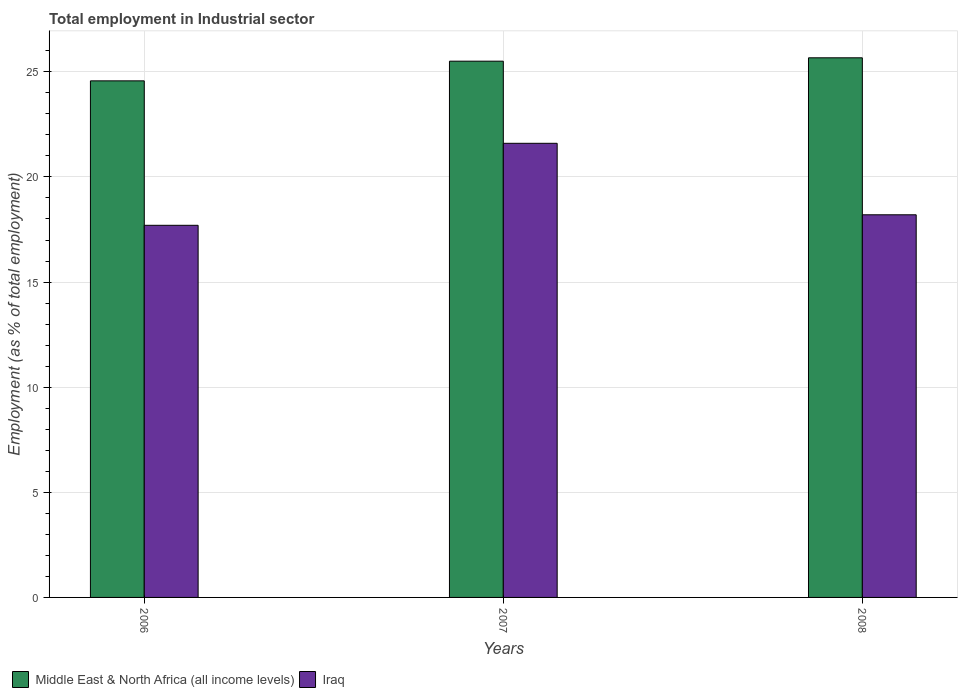How many groups of bars are there?
Offer a very short reply. 3. Are the number of bars on each tick of the X-axis equal?
Ensure brevity in your answer.  Yes. How many bars are there on the 3rd tick from the left?
Offer a very short reply. 2. What is the label of the 2nd group of bars from the left?
Your answer should be compact. 2007. What is the employment in industrial sector in Middle East & North Africa (all income levels) in 2008?
Ensure brevity in your answer.  25.67. Across all years, what is the maximum employment in industrial sector in Middle East & North Africa (all income levels)?
Offer a very short reply. 25.67. Across all years, what is the minimum employment in industrial sector in Iraq?
Provide a succinct answer. 17.7. In which year was the employment in industrial sector in Iraq maximum?
Provide a short and direct response. 2007. What is the total employment in industrial sector in Iraq in the graph?
Provide a succinct answer. 57.5. What is the difference between the employment in industrial sector in Middle East & North Africa (all income levels) in 2006 and that in 2007?
Give a very brief answer. -0.94. What is the difference between the employment in industrial sector in Iraq in 2008 and the employment in industrial sector in Middle East & North Africa (all income levels) in 2007?
Your answer should be compact. -7.31. What is the average employment in industrial sector in Iraq per year?
Make the answer very short. 19.17. In the year 2008, what is the difference between the employment in industrial sector in Iraq and employment in industrial sector in Middle East & North Africa (all income levels)?
Provide a succinct answer. -7.47. In how many years, is the employment in industrial sector in Middle East & North Africa (all income levels) greater than 20 %?
Ensure brevity in your answer.  3. What is the ratio of the employment in industrial sector in Iraq in 2006 to that in 2008?
Make the answer very short. 0.97. Is the employment in industrial sector in Iraq in 2007 less than that in 2008?
Offer a very short reply. No. Is the difference between the employment in industrial sector in Iraq in 2006 and 2007 greater than the difference between the employment in industrial sector in Middle East & North Africa (all income levels) in 2006 and 2007?
Provide a succinct answer. No. What is the difference between the highest and the second highest employment in industrial sector in Middle East & North Africa (all income levels)?
Your response must be concise. 0.16. What is the difference between the highest and the lowest employment in industrial sector in Middle East & North Africa (all income levels)?
Ensure brevity in your answer.  1.1. In how many years, is the employment in industrial sector in Iraq greater than the average employment in industrial sector in Iraq taken over all years?
Keep it short and to the point. 1. What does the 1st bar from the left in 2007 represents?
Your answer should be compact. Middle East & North Africa (all income levels). What does the 2nd bar from the right in 2006 represents?
Your response must be concise. Middle East & North Africa (all income levels). How many bars are there?
Keep it short and to the point. 6. What is the difference between two consecutive major ticks on the Y-axis?
Your answer should be very brief. 5. Does the graph contain any zero values?
Your response must be concise. No. Where does the legend appear in the graph?
Your response must be concise. Bottom left. How many legend labels are there?
Keep it short and to the point. 2. How are the legend labels stacked?
Offer a very short reply. Horizontal. What is the title of the graph?
Offer a very short reply. Total employment in Industrial sector. What is the label or title of the X-axis?
Provide a short and direct response. Years. What is the label or title of the Y-axis?
Keep it short and to the point. Employment (as % of total employment). What is the Employment (as % of total employment) in Middle East & North Africa (all income levels) in 2006?
Your answer should be compact. 24.57. What is the Employment (as % of total employment) of Iraq in 2006?
Keep it short and to the point. 17.7. What is the Employment (as % of total employment) of Middle East & North Africa (all income levels) in 2007?
Give a very brief answer. 25.51. What is the Employment (as % of total employment) in Iraq in 2007?
Ensure brevity in your answer.  21.6. What is the Employment (as % of total employment) in Middle East & North Africa (all income levels) in 2008?
Make the answer very short. 25.67. What is the Employment (as % of total employment) in Iraq in 2008?
Ensure brevity in your answer.  18.2. Across all years, what is the maximum Employment (as % of total employment) in Middle East & North Africa (all income levels)?
Your answer should be compact. 25.67. Across all years, what is the maximum Employment (as % of total employment) of Iraq?
Your answer should be compact. 21.6. Across all years, what is the minimum Employment (as % of total employment) of Middle East & North Africa (all income levels)?
Your answer should be compact. 24.57. Across all years, what is the minimum Employment (as % of total employment) of Iraq?
Provide a succinct answer. 17.7. What is the total Employment (as % of total employment) of Middle East & North Africa (all income levels) in the graph?
Offer a terse response. 75.74. What is the total Employment (as % of total employment) in Iraq in the graph?
Your answer should be compact. 57.5. What is the difference between the Employment (as % of total employment) in Middle East & North Africa (all income levels) in 2006 and that in 2007?
Provide a short and direct response. -0.94. What is the difference between the Employment (as % of total employment) in Iraq in 2006 and that in 2007?
Your answer should be compact. -3.9. What is the difference between the Employment (as % of total employment) in Middle East & North Africa (all income levels) in 2006 and that in 2008?
Your answer should be very brief. -1.1. What is the difference between the Employment (as % of total employment) in Iraq in 2006 and that in 2008?
Your response must be concise. -0.5. What is the difference between the Employment (as % of total employment) in Middle East & North Africa (all income levels) in 2007 and that in 2008?
Give a very brief answer. -0.16. What is the difference between the Employment (as % of total employment) in Iraq in 2007 and that in 2008?
Your response must be concise. 3.4. What is the difference between the Employment (as % of total employment) of Middle East & North Africa (all income levels) in 2006 and the Employment (as % of total employment) of Iraq in 2007?
Provide a short and direct response. 2.97. What is the difference between the Employment (as % of total employment) of Middle East & North Africa (all income levels) in 2006 and the Employment (as % of total employment) of Iraq in 2008?
Keep it short and to the point. 6.37. What is the difference between the Employment (as % of total employment) of Middle East & North Africa (all income levels) in 2007 and the Employment (as % of total employment) of Iraq in 2008?
Your response must be concise. 7.31. What is the average Employment (as % of total employment) of Middle East & North Africa (all income levels) per year?
Your response must be concise. 25.25. What is the average Employment (as % of total employment) in Iraq per year?
Your response must be concise. 19.17. In the year 2006, what is the difference between the Employment (as % of total employment) in Middle East & North Africa (all income levels) and Employment (as % of total employment) in Iraq?
Keep it short and to the point. 6.87. In the year 2007, what is the difference between the Employment (as % of total employment) of Middle East & North Africa (all income levels) and Employment (as % of total employment) of Iraq?
Your response must be concise. 3.91. In the year 2008, what is the difference between the Employment (as % of total employment) of Middle East & North Africa (all income levels) and Employment (as % of total employment) of Iraq?
Provide a short and direct response. 7.47. What is the ratio of the Employment (as % of total employment) in Middle East & North Africa (all income levels) in 2006 to that in 2007?
Your answer should be compact. 0.96. What is the ratio of the Employment (as % of total employment) in Iraq in 2006 to that in 2007?
Provide a short and direct response. 0.82. What is the ratio of the Employment (as % of total employment) of Middle East & North Africa (all income levels) in 2006 to that in 2008?
Provide a short and direct response. 0.96. What is the ratio of the Employment (as % of total employment) of Iraq in 2006 to that in 2008?
Offer a terse response. 0.97. What is the ratio of the Employment (as % of total employment) of Middle East & North Africa (all income levels) in 2007 to that in 2008?
Offer a terse response. 0.99. What is the ratio of the Employment (as % of total employment) in Iraq in 2007 to that in 2008?
Provide a short and direct response. 1.19. What is the difference between the highest and the second highest Employment (as % of total employment) in Middle East & North Africa (all income levels)?
Ensure brevity in your answer.  0.16. What is the difference between the highest and the lowest Employment (as % of total employment) in Middle East & North Africa (all income levels)?
Provide a short and direct response. 1.1. What is the difference between the highest and the lowest Employment (as % of total employment) of Iraq?
Make the answer very short. 3.9. 